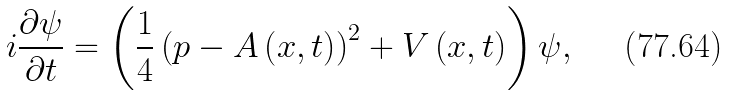<formula> <loc_0><loc_0><loc_500><loc_500>i \frac { \partial \psi } { \partial t } = \left ( \frac { 1 } { 4 } \left ( p - A \left ( x , t \right ) \right ) ^ { 2 } + V \left ( x , t \right ) \right ) \psi ,</formula> 